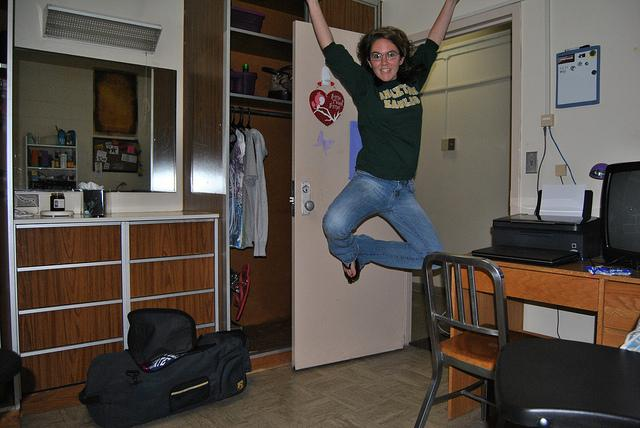Where is the woman jumping? dorm room 